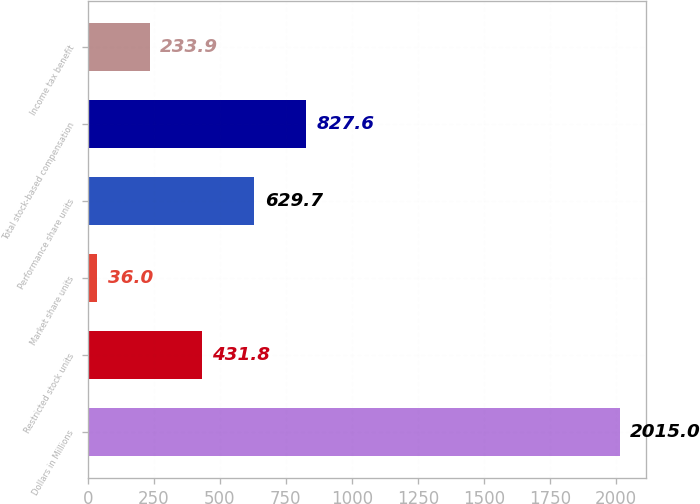Convert chart. <chart><loc_0><loc_0><loc_500><loc_500><bar_chart><fcel>Dollars in Millions<fcel>Restricted stock units<fcel>Market share units<fcel>Performance share units<fcel>Total stock-based compensation<fcel>Income tax benefit<nl><fcel>2015<fcel>431.8<fcel>36<fcel>629.7<fcel>827.6<fcel>233.9<nl></chart> 